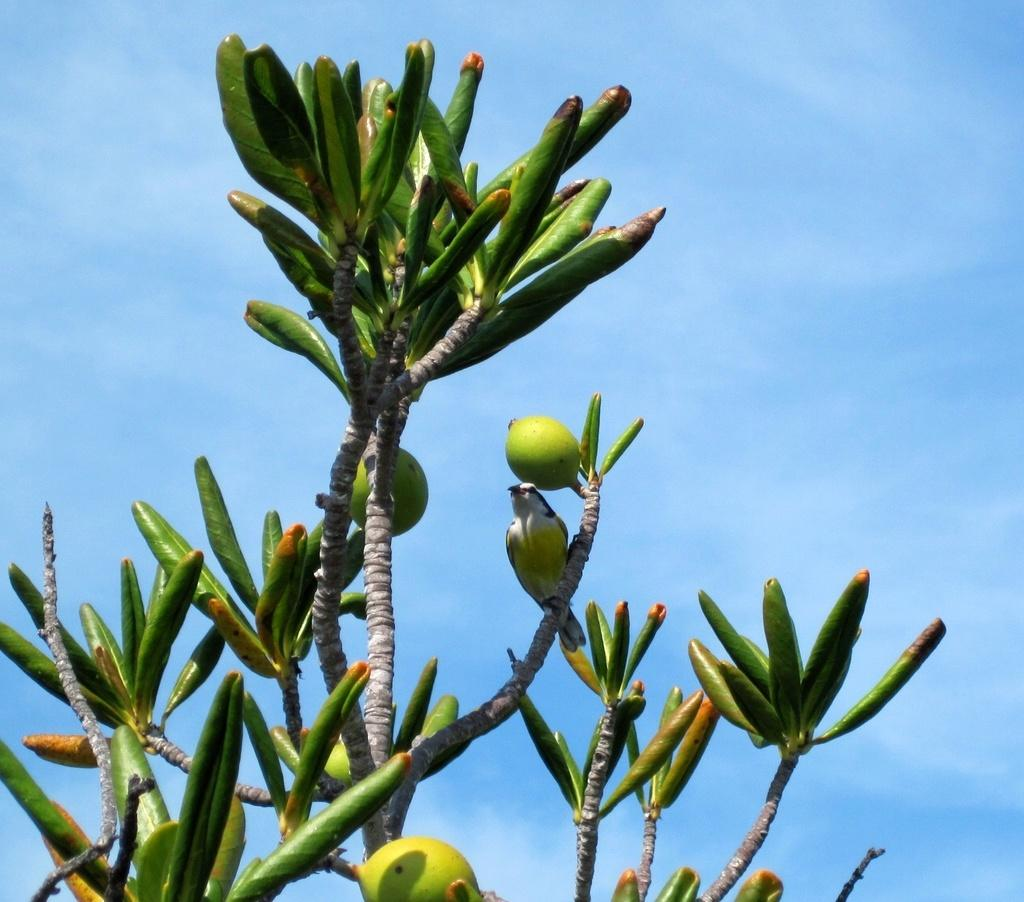What type of animal is present in the image? There is a bird in the image. Where is the bird located? The bird is on a plant in the image. What else can be seen on the plant? There are fruits and buds in the image. What type of seed is the bird eating in the image? There is no seed visible in the image, and the bird is not shown eating anything. 